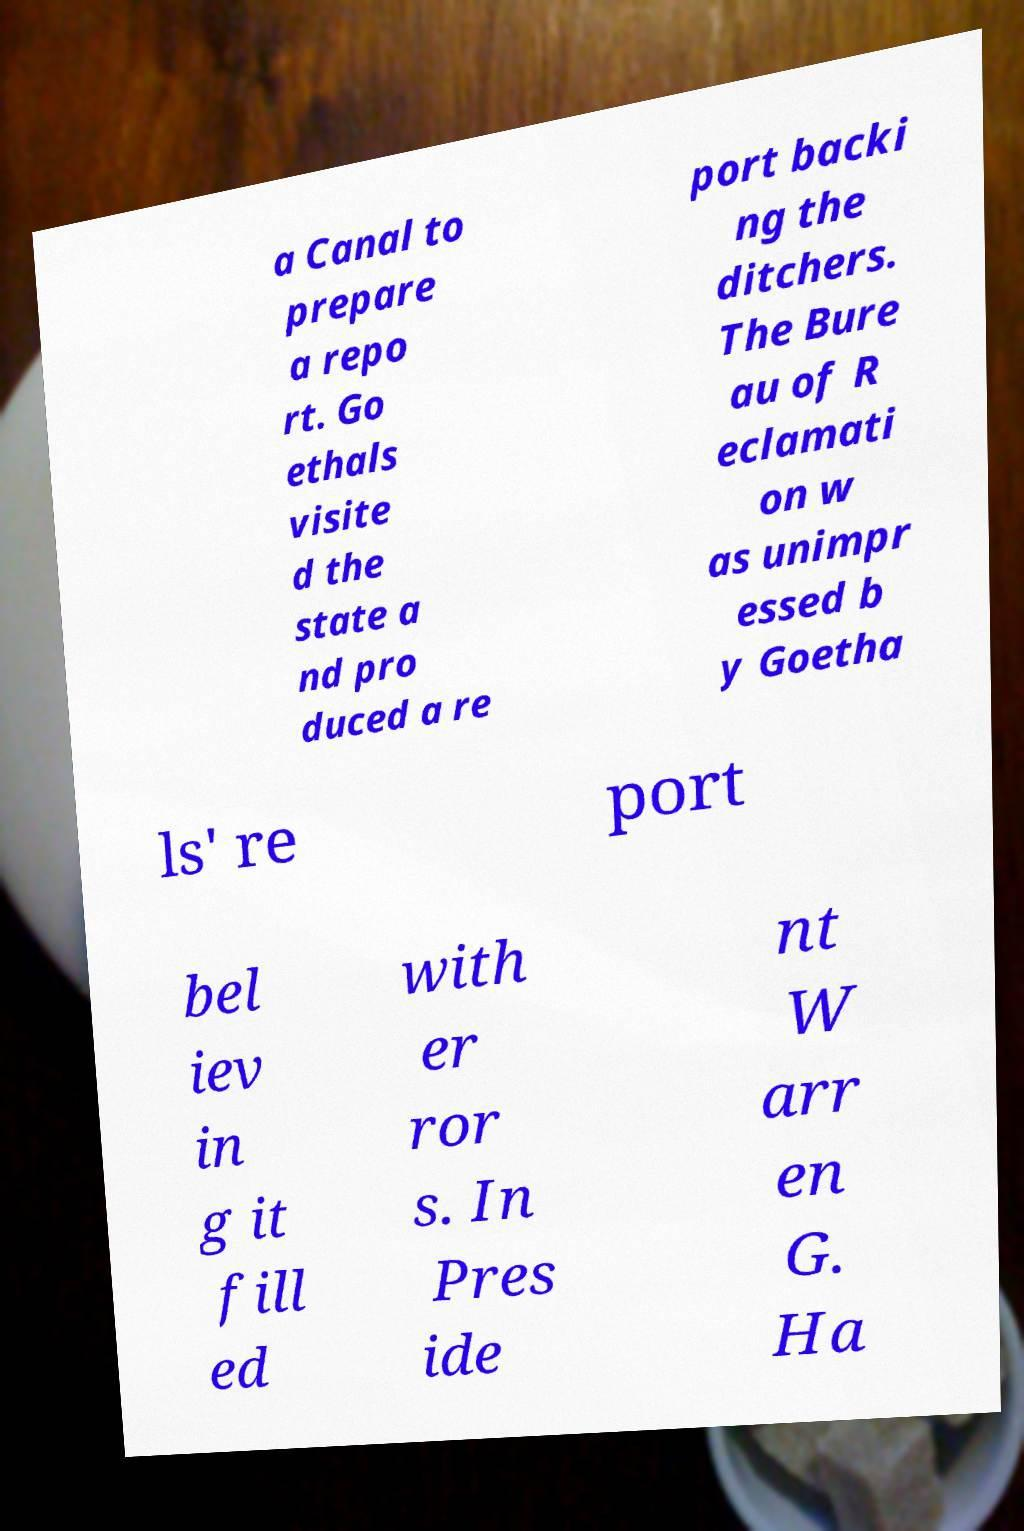I need the written content from this picture converted into text. Can you do that? a Canal to prepare a repo rt. Go ethals visite d the state a nd pro duced a re port backi ng the ditchers. The Bure au of R eclamati on w as unimpr essed b y Goetha ls' re port bel iev in g it fill ed with er ror s. In Pres ide nt W arr en G. Ha 